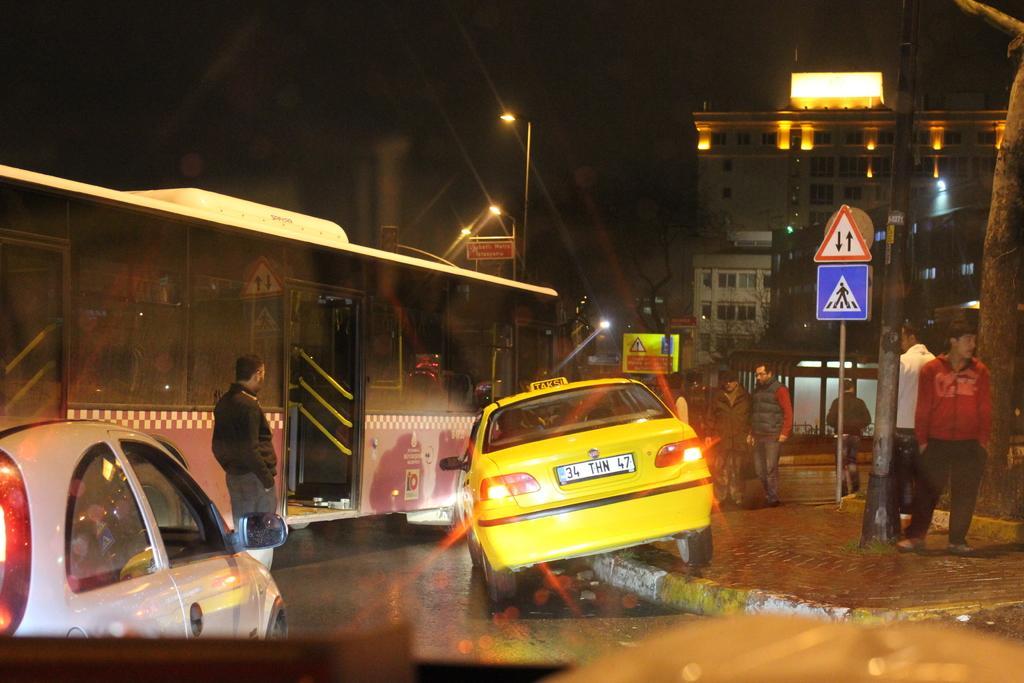Could you give a brief overview of what you see in this image? As we can see in the image there is a bus, few people here and there, cars, street lamps, sign pole, building and sky. The image is little dark. 